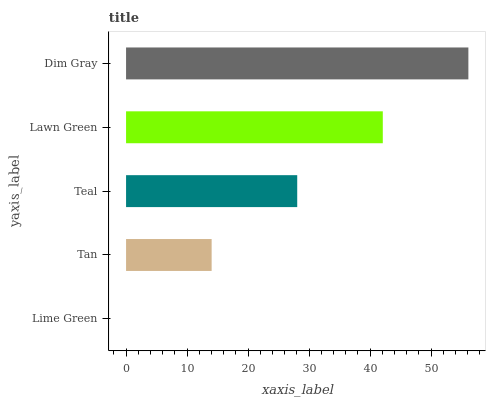Is Lime Green the minimum?
Answer yes or no. Yes. Is Dim Gray the maximum?
Answer yes or no. Yes. Is Tan the minimum?
Answer yes or no. No. Is Tan the maximum?
Answer yes or no. No. Is Tan greater than Lime Green?
Answer yes or no. Yes. Is Lime Green less than Tan?
Answer yes or no. Yes. Is Lime Green greater than Tan?
Answer yes or no. No. Is Tan less than Lime Green?
Answer yes or no. No. Is Teal the high median?
Answer yes or no. Yes. Is Teal the low median?
Answer yes or no. Yes. Is Dim Gray the high median?
Answer yes or no. No. Is Tan the low median?
Answer yes or no. No. 